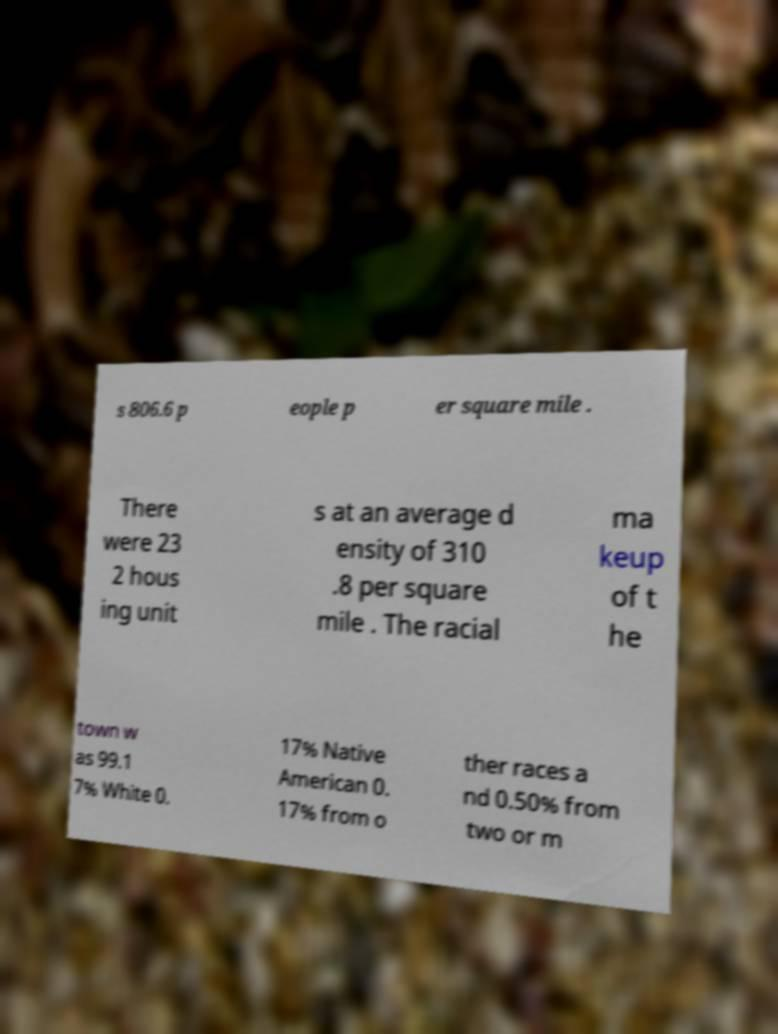Could you extract and type out the text from this image? s 806.6 p eople p er square mile . There were 23 2 hous ing unit s at an average d ensity of 310 .8 per square mile . The racial ma keup of t he town w as 99.1 7% White 0. 17% Native American 0. 17% from o ther races a nd 0.50% from two or m 